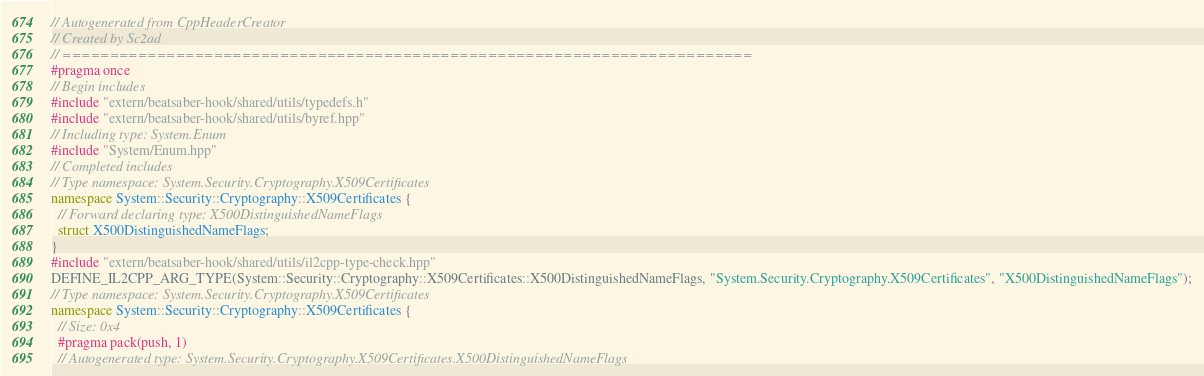<code> <loc_0><loc_0><loc_500><loc_500><_C++_>// Autogenerated from CppHeaderCreator
// Created by Sc2ad
// =========================================================================
#pragma once
// Begin includes
#include "extern/beatsaber-hook/shared/utils/typedefs.h"
#include "extern/beatsaber-hook/shared/utils/byref.hpp"
// Including type: System.Enum
#include "System/Enum.hpp"
// Completed includes
// Type namespace: System.Security.Cryptography.X509Certificates
namespace System::Security::Cryptography::X509Certificates {
  // Forward declaring type: X500DistinguishedNameFlags
  struct X500DistinguishedNameFlags;
}
#include "extern/beatsaber-hook/shared/utils/il2cpp-type-check.hpp"
DEFINE_IL2CPP_ARG_TYPE(System::Security::Cryptography::X509Certificates::X500DistinguishedNameFlags, "System.Security.Cryptography.X509Certificates", "X500DistinguishedNameFlags");
// Type namespace: System.Security.Cryptography.X509Certificates
namespace System::Security::Cryptography::X509Certificates {
  // Size: 0x4
  #pragma pack(push, 1)
  // Autogenerated type: System.Security.Cryptography.X509Certificates.X500DistinguishedNameFlags</code> 